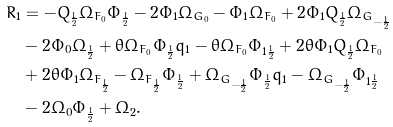<formula> <loc_0><loc_0><loc_500><loc_500>R _ { 1 } & = - Q _ { \frac { 1 } { 2 } } \Omega _ { F _ { 0 } } \Phi _ { \frac { 1 } { 2 } } - 2 \Phi _ { 1 } \Omega _ { G _ { 0 } } - \Phi _ { 1 } \Omega _ { F _ { 0 } } + 2 \Phi _ { 1 } Q _ { \frac { 1 } { 2 } } \Omega _ { G _ { - \frac { 1 } { 2 } } } \\ & - 2 \Phi _ { 0 } \Omega _ { \frac { 1 } { 2 } } + \theta \Omega _ { F _ { 0 } } \Phi _ { \frac { 1 } { 2 } } q _ { 1 } - \theta \Omega _ { F _ { 0 } } \Phi _ { 1 \frac { 1 } { 2 } } + 2 \theta \Phi _ { 1 } Q _ { \frac { 1 } { 2 } } \Omega _ { F _ { 0 } } \\ & + 2 \theta \Phi _ { 1 } \Omega _ { F _ { \frac { 1 } { 2 } } } - \Omega _ { F _ { \frac { 1 } { 2 } } } \Phi _ { \frac { 1 } { 2 } } + \Omega _ { G _ { - \frac { 1 } { 2 } } } \Phi _ { \frac { 1 } { 2 } } q _ { 1 } - \Omega _ { G _ { - \frac { 1 } { 2 } } } \Phi _ { 1 \frac { 1 } { 2 } } \\ & - 2 \Omega _ { 0 } \Phi _ { \frac { 1 } { 2 } } + \Omega _ { 2 } .</formula> 